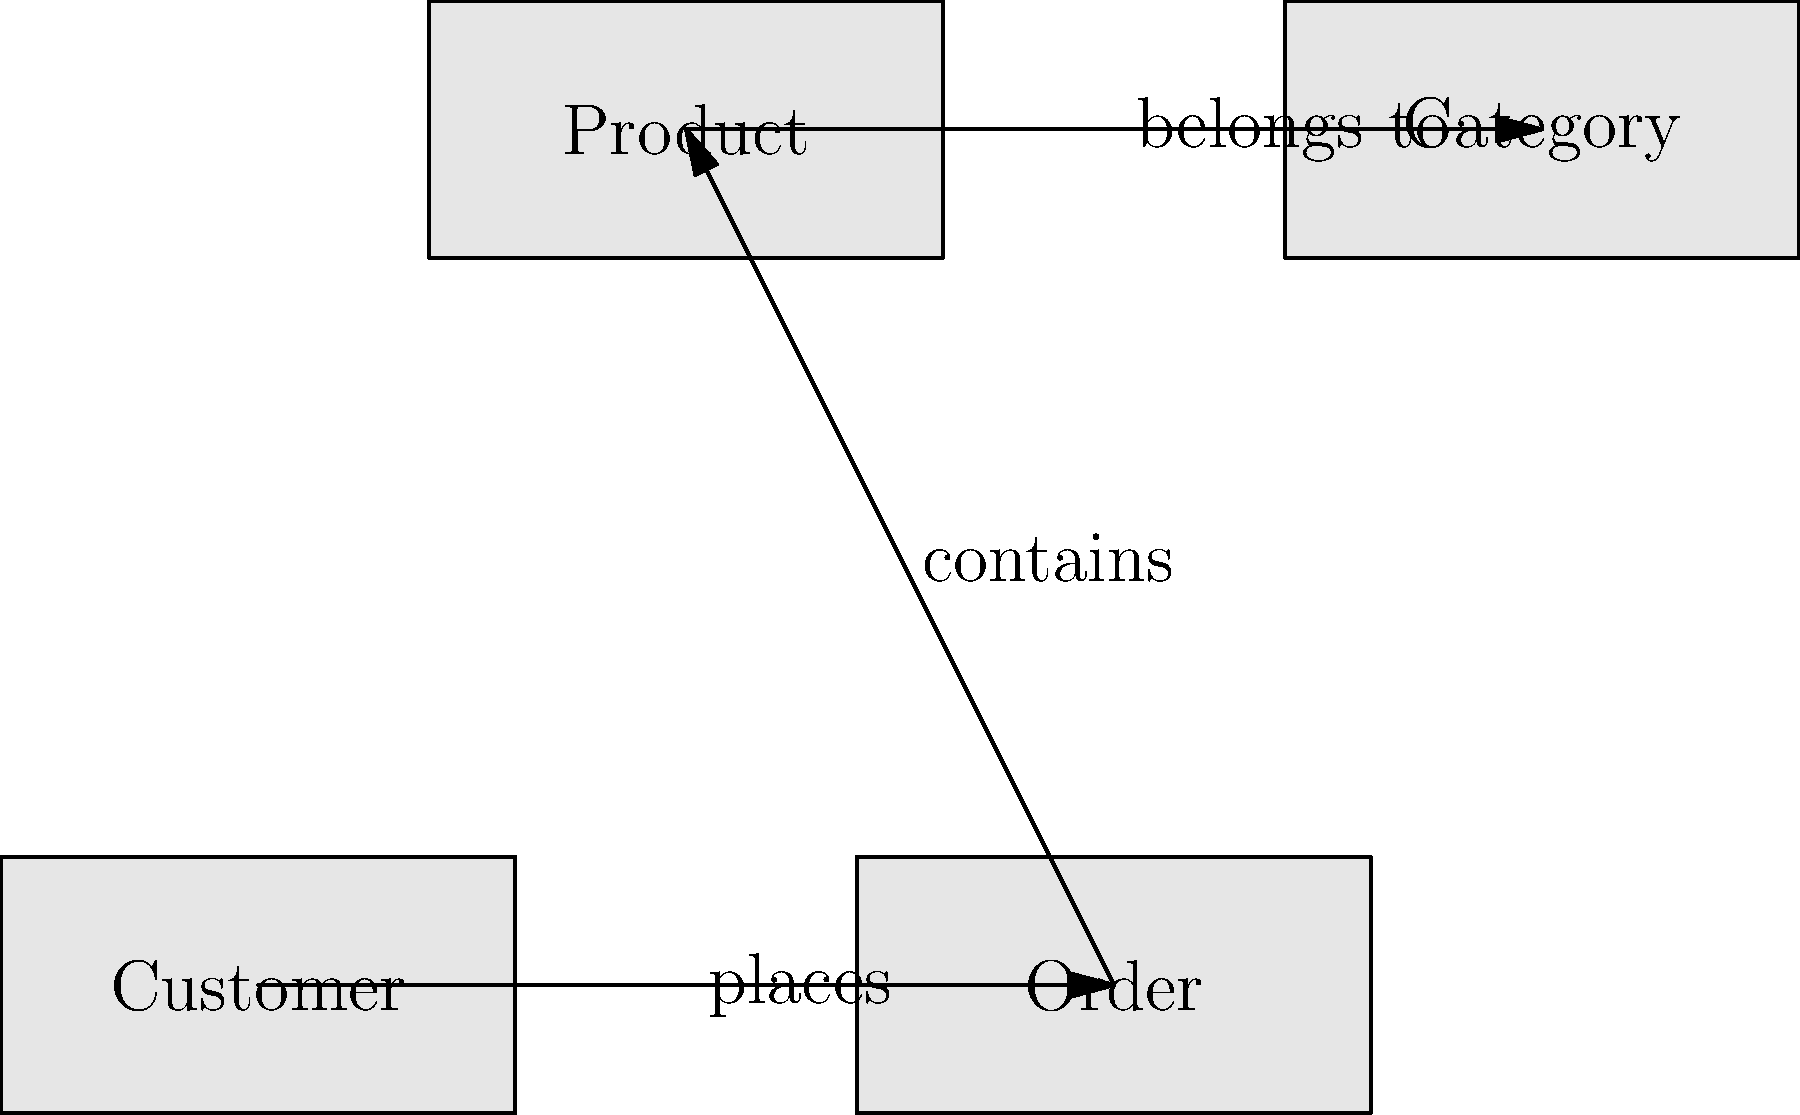Based on the entity-relationship diagram provided, which entity is central to the database schema and has direct relationships with two other entities? Explain your reasoning. To determine the central entity in this database schema, we need to analyze the relationships between the entities:

1. First, identify all entities in the diagram:
   - Customer
   - Order
   - Product
   - Category

2. Examine the relationships between these entities:
   - Customer "places" Order
   - Order "contains" Product
   - Product "belongs to" Category

3. Count the number of direct relationships for each entity:
   - Customer: 1 relationship (with Order)
   - Order: 2 relationships (with Customer and Product)
   - Product: 2 relationships (with Order and Category)
   - Category: 1 relationship (with Product)

4. Identify the entities with the most direct relationships:
   Both Order and Product have 2 direct relationships each.

5. Consider the nature of these relationships:
   - Order is connected to both Customer and Product, linking the user action (placing an order) with the items being ordered.
   - Product is connected to Order and Category, but doesn't directly link different aspects of the business process.

6. Conclusion:
   Order is the central entity because it connects the customer's action (placing an order) with the items being ordered (products). It serves as a bridge between the user-facing aspect (Customer) and the inventory aspect (Product) of the system.
Answer: Order 